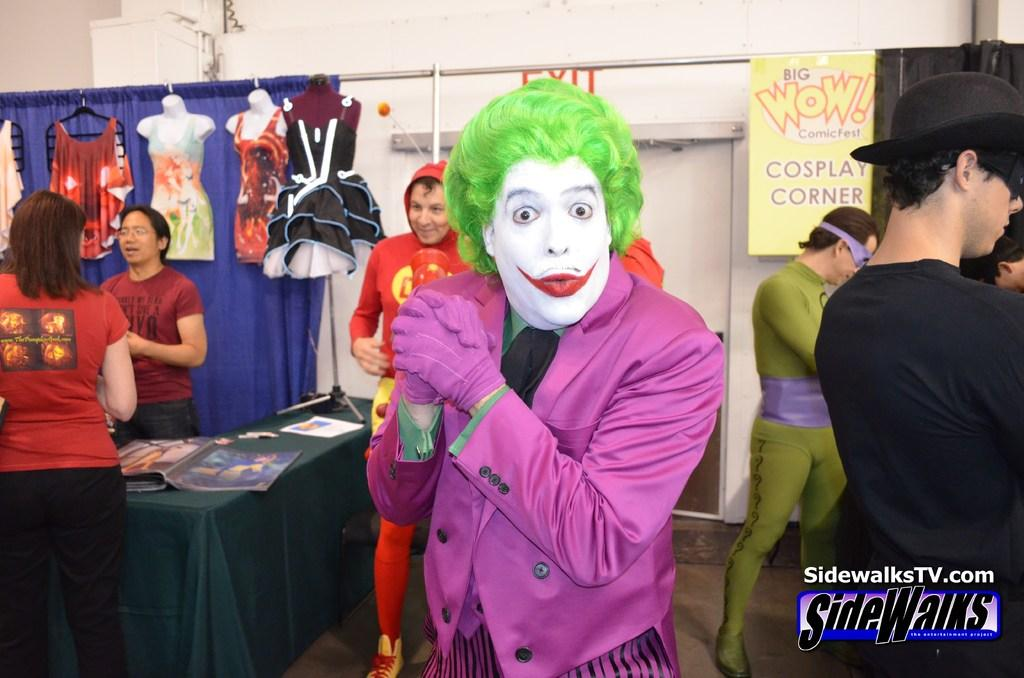Provide a one-sentence caption for the provided image. The joker standing in front of a sign that has Wow outlined in red. 